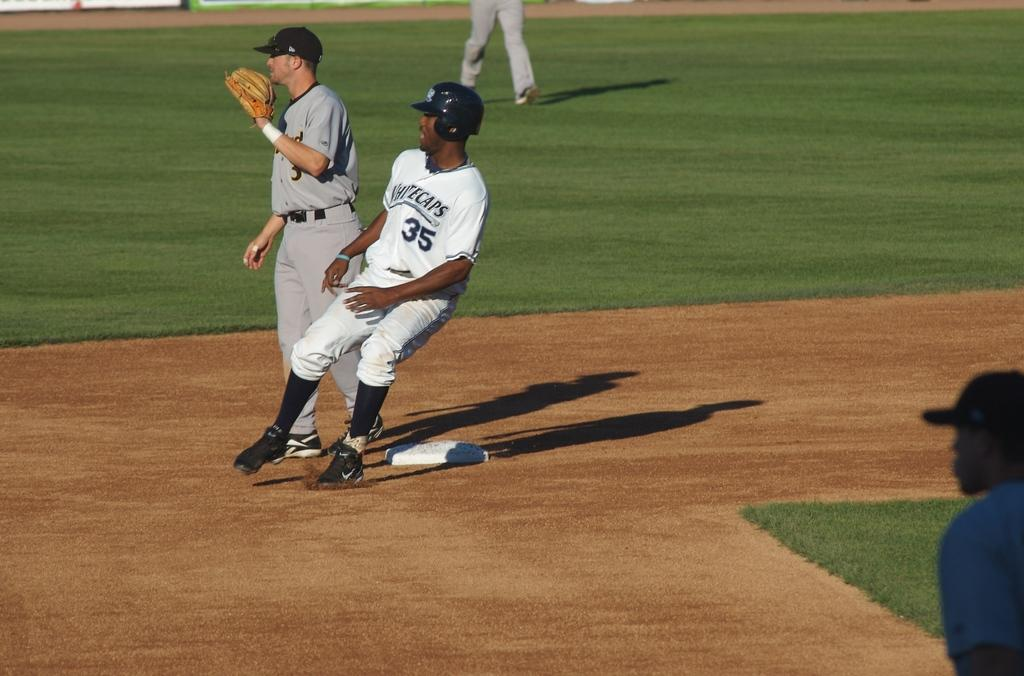<image>
Offer a succinct explanation of the picture presented. A man wearing a white jersey with the number 35 on it is standing near a plate on a baseball field. 